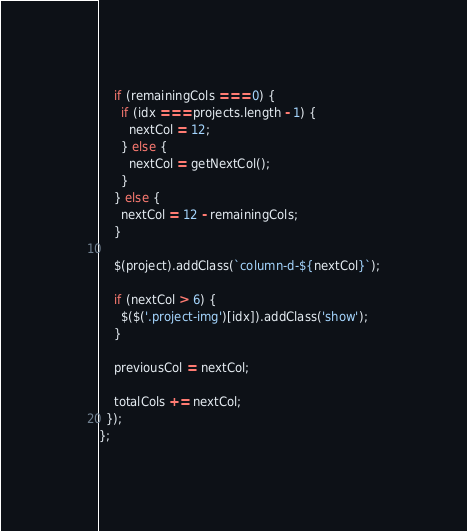<code> <loc_0><loc_0><loc_500><loc_500><_JavaScript_>    if (remainingCols === 0) {
      if (idx === projects.length - 1) {
        nextCol = 12;
      } else {
        nextCol = getNextCol();
      }
    } else {
      nextCol = 12 - remainingCols;
    }

    $(project).addClass(`column-d-${nextCol}`);

    if (nextCol > 6) {
      $($('.project-img')[idx]).addClass('show');
    }

    previousCol = nextCol;

    totalCols += nextCol;
  });
};

</code> 